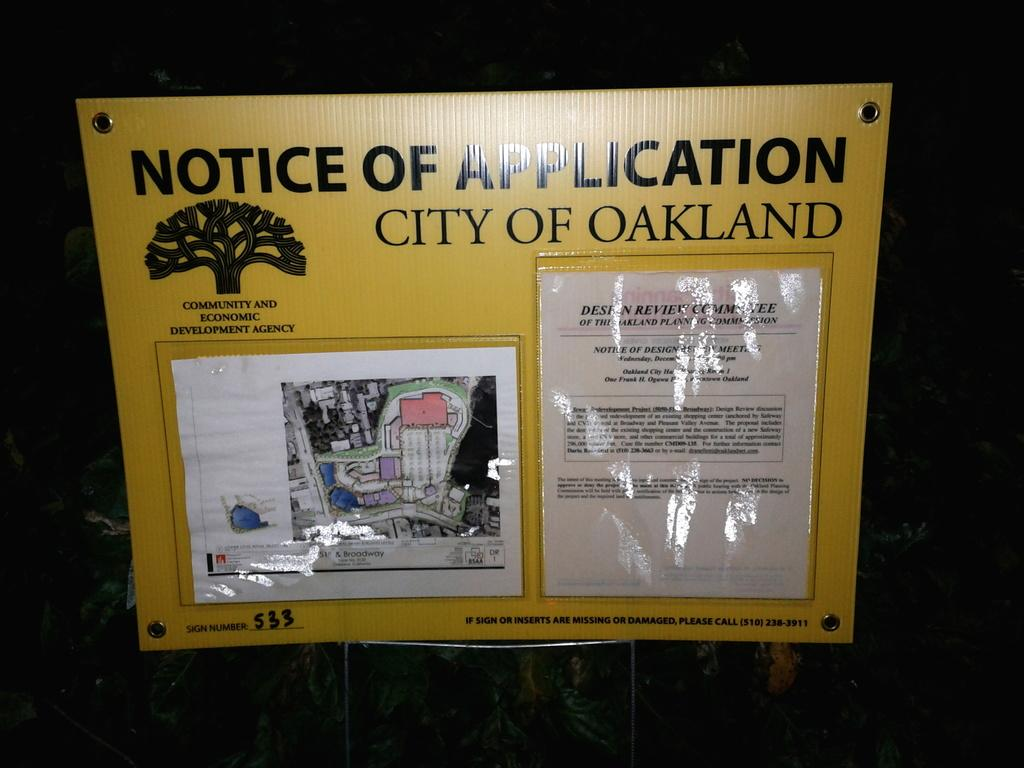<image>
Render a clear and concise summary of the photo. A yellow sign displayed that says, Notice of Application City of Oakland at the top. 